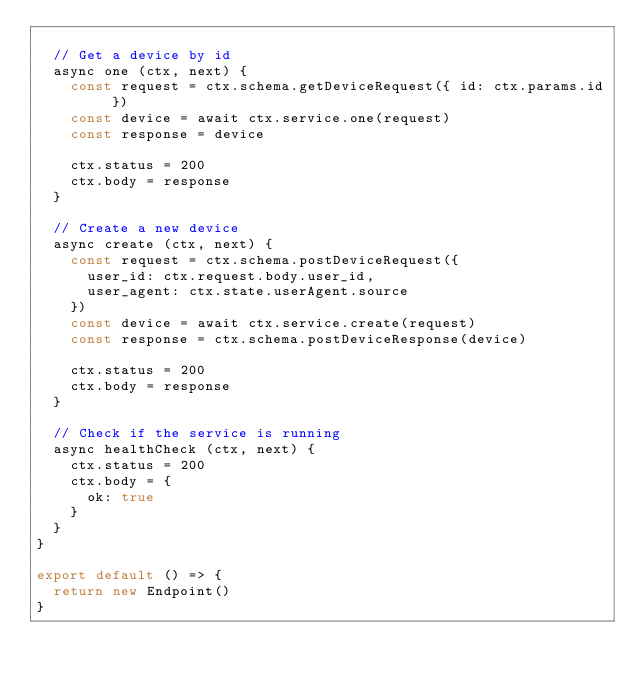Convert code to text. <code><loc_0><loc_0><loc_500><loc_500><_JavaScript_>
  // Get a device by id
  async one (ctx, next) {
    const request = ctx.schema.getDeviceRequest({ id: ctx.params.id })
    const device = await ctx.service.one(request)
    const response = device

    ctx.status = 200
    ctx.body = response
  }

  // Create a new device
  async create (ctx, next) {
    const request = ctx.schema.postDeviceRequest({
      user_id: ctx.request.body.user_id,
      user_agent: ctx.state.userAgent.source
    })
    const device = await ctx.service.create(request)
    const response = ctx.schema.postDeviceResponse(device)

    ctx.status = 200
    ctx.body = response
  }

  // Check if the service is running
  async healthCheck (ctx, next) {
    ctx.status = 200
    ctx.body = {
      ok: true
    }
  }
}

export default () => {
  return new Endpoint()
}
</code> 